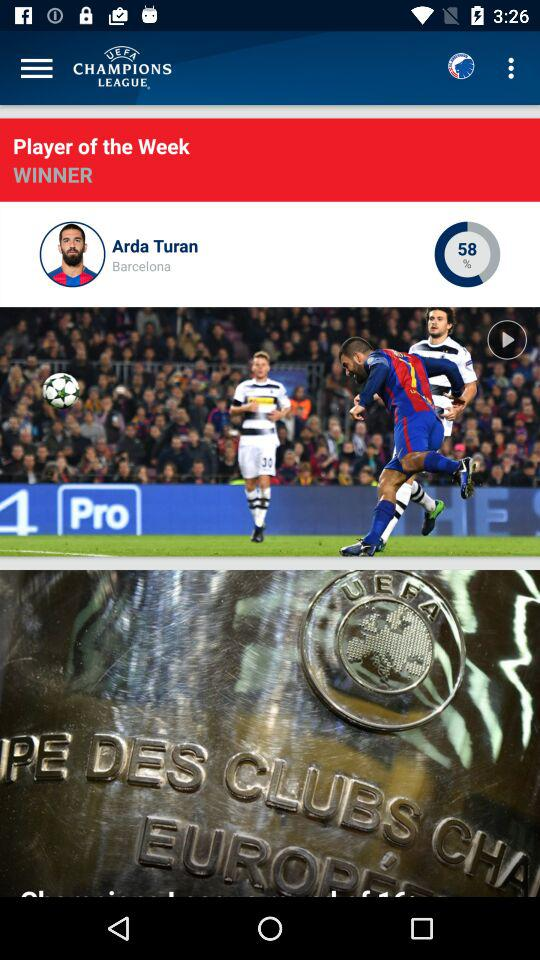What is the efficiency percentage of Arda Turan? The efficiency percentage of Arda Turan is 58. 